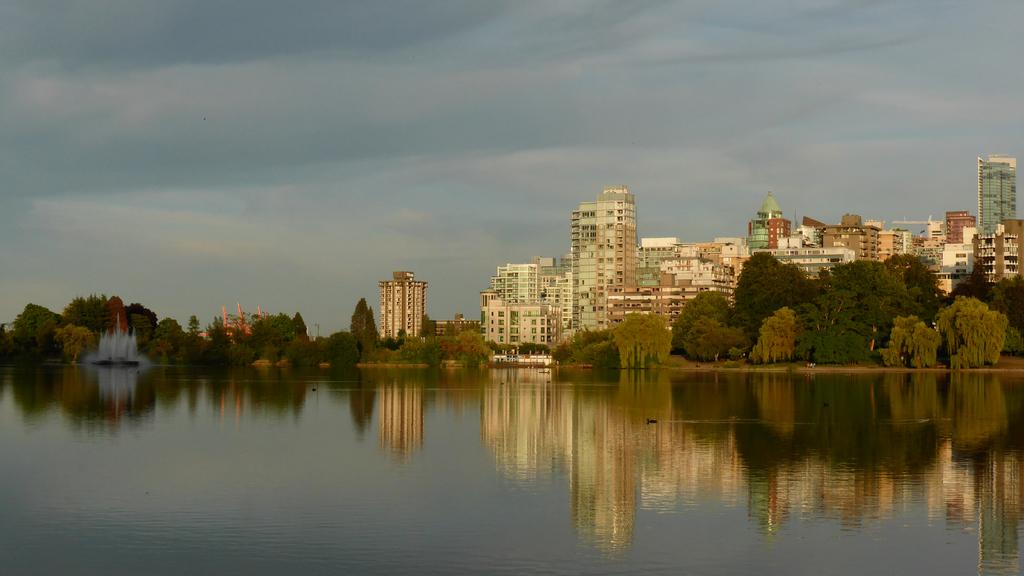What can be seen in the foreground of the image? There is water in the foreground of the image. What is visible in the background of the image? There are trees, a fountain, buildings, and the sky visible in the background of the image. Can you describe the sky in the image? The sky is visible in the background of the image, and there is a cloud visible in the sky. How many books are stacked on the coast in the image? There are no books or coast present in the image. What is the total amount of debt visible in the image? There is no reference to debt in the image. 